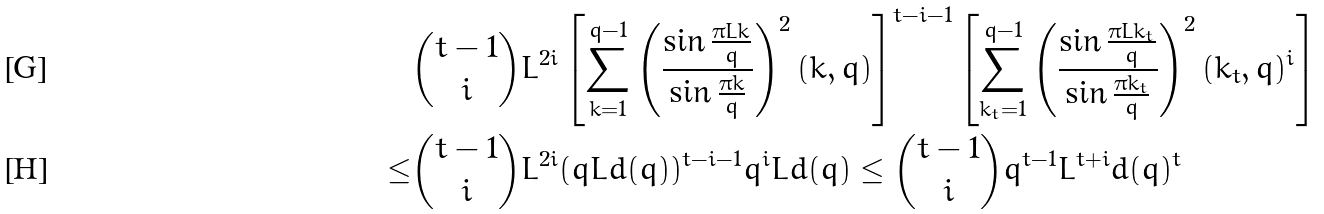Convert formula to latex. <formula><loc_0><loc_0><loc_500><loc_500>& \binom { t - 1 } { i } L ^ { 2 i } \left [ \sum _ { k = 1 } ^ { q - 1 } \left ( \frac { \sin \frac { \pi L k } { q } } { \sin \frac { \pi k } { q } } \right ) ^ { 2 } ( k , q ) \right ] ^ { t - i - 1 } \left [ \sum _ { k _ { t } = 1 } ^ { q - 1 } \left ( \frac { \sin \frac { \pi L k _ { t } } { q } } { \sin \frac { \pi k _ { t } } { q } } \right ) ^ { 2 } ( k _ { t } , q ) ^ { i } \right ] \\ \leq & \binom { t - 1 } { i } L ^ { 2 i } ( q L d ( q ) ) ^ { t - i - 1 } q ^ { i } L d ( q ) \leq \binom { t - 1 } { i } q ^ { t - 1 } L ^ { t + i } d ( q ) ^ { t }</formula> 